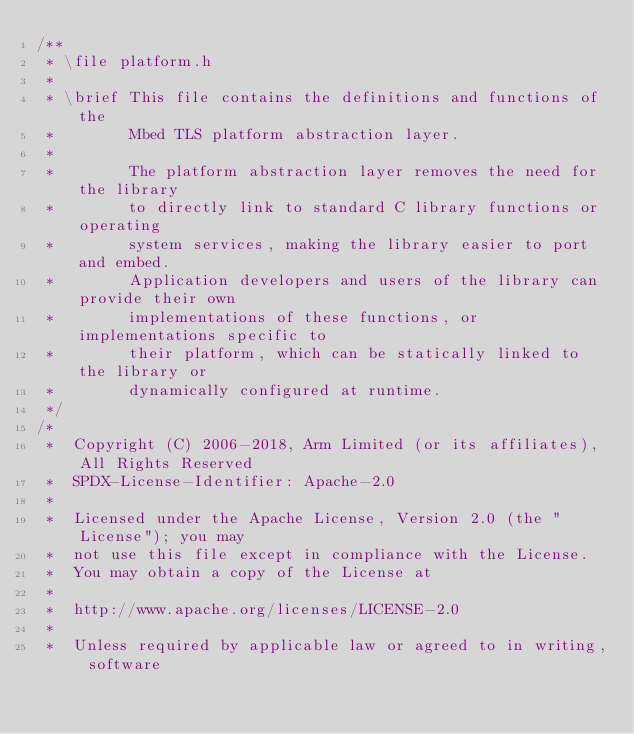Convert code to text. <code><loc_0><loc_0><loc_500><loc_500><_C_>/**
 * \file platform.h
 *
 * \brief This file contains the definitions and functions of the
 *        Mbed TLS platform abstraction layer.
 *
 *        The platform abstraction layer removes the need for the library
 *        to directly link to standard C library functions or operating
 *        system services, making the library easier to port and embed.
 *        Application developers and users of the library can provide their own
 *        implementations of these functions, or implementations specific to
 *        their platform, which can be statically linked to the library or
 *        dynamically configured at runtime.
 */
/*
 *  Copyright (C) 2006-2018, Arm Limited (or its affiliates), All Rights Reserved
 *  SPDX-License-Identifier: Apache-2.0
 *
 *  Licensed under the Apache License, Version 2.0 (the "License"); you may
 *  not use this file except in compliance with the License.
 *  You may obtain a copy of the License at
 *
 *  http://www.apache.org/licenses/LICENSE-2.0
 *
 *  Unless required by applicable law or agreed to in writing, software</code> 